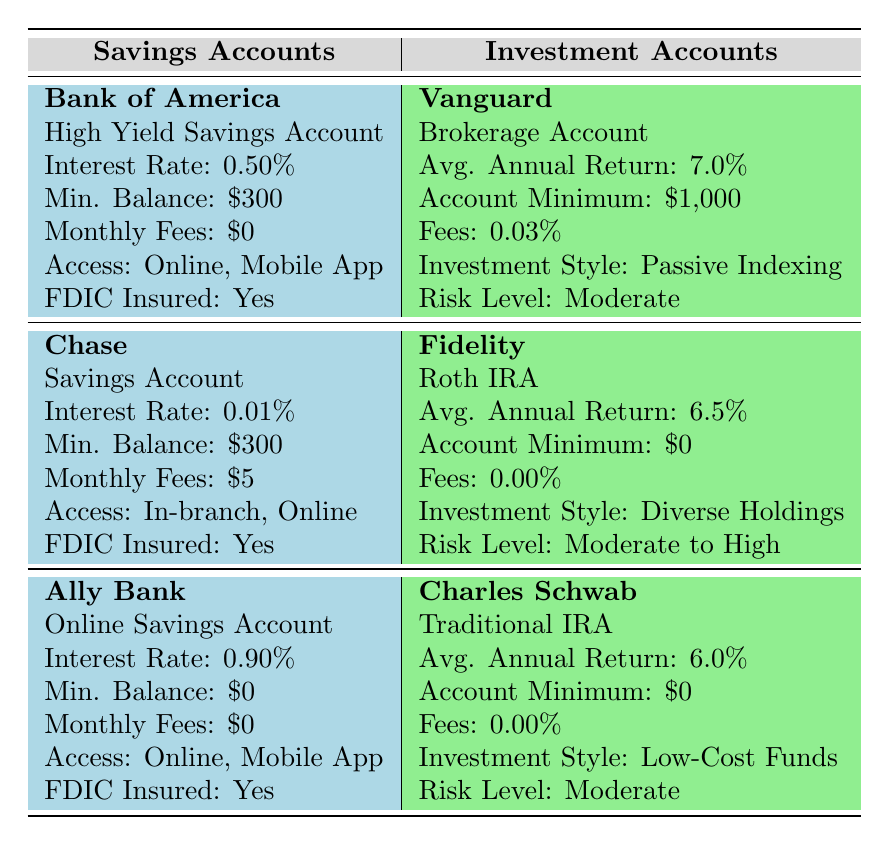What is the interest rate of Ally Bank's savings account? The table shows that Ally Bank's account type is "Online Savings Account" and lists its interest rate as 0.90%.
Answer: 0.90% Which investment account has the highest average annual return? By comparing the average annual returns of all investment accounts, Vanguard has the highest return at 7.0%.
Answer: Vanguard Does Chase’s savings account have a monthly fee? According to the table, Chase’s savings account charges a monthly fee of $5.
Answer: Yes What is the difference in average annual return between Vanguard and Fidelity? Vanguard offers an average annual return of 7.0%, and Fidelity offers 6.5%. The difference is 7.0% - 6.5% = 0.5%.
Answer: 0.5% Are all savings accounts listed FDIC insured? The table states that all three savings accounts—Bank of America, Chase, and Ally Bank—are FDIC insured.
Answer: Yes Which account type requires the lowest minimum balance? Ally Bank’sOnline Savings Account has a minimum balance of $0, and this is lower than the other minimum balances of $300 and $1000 for the other accounts.
Answer: $0 How does the risk level of Fidelity's account compare to that of Vanguard's account? Fidelity's risk level is moderate to high, whereas Vanguard's risk level is moderate. This indicates that Fidelity’s account has a higher risk threshold compared to Vanguard’s.
Answer: Higher What is the total monthly fee for maintaining both a Chase savings account and a Bank of America savings account? Chase’s monthly fee is $5 and Bank of America’s is $0. Therefore, the total monthly fee is $5 + $0 = $5.
Answer: $5 What benefits does Ally Bank offer compared to Chase in terms of fees? Ally Bank has a monthly fee of $0 and requires no minimum balance, while Chase charges a $5 monthly fee and requires a minimum balance of $300. Therefore, Ally Bank has better fee benefits.
Answer: Better fee benefits 